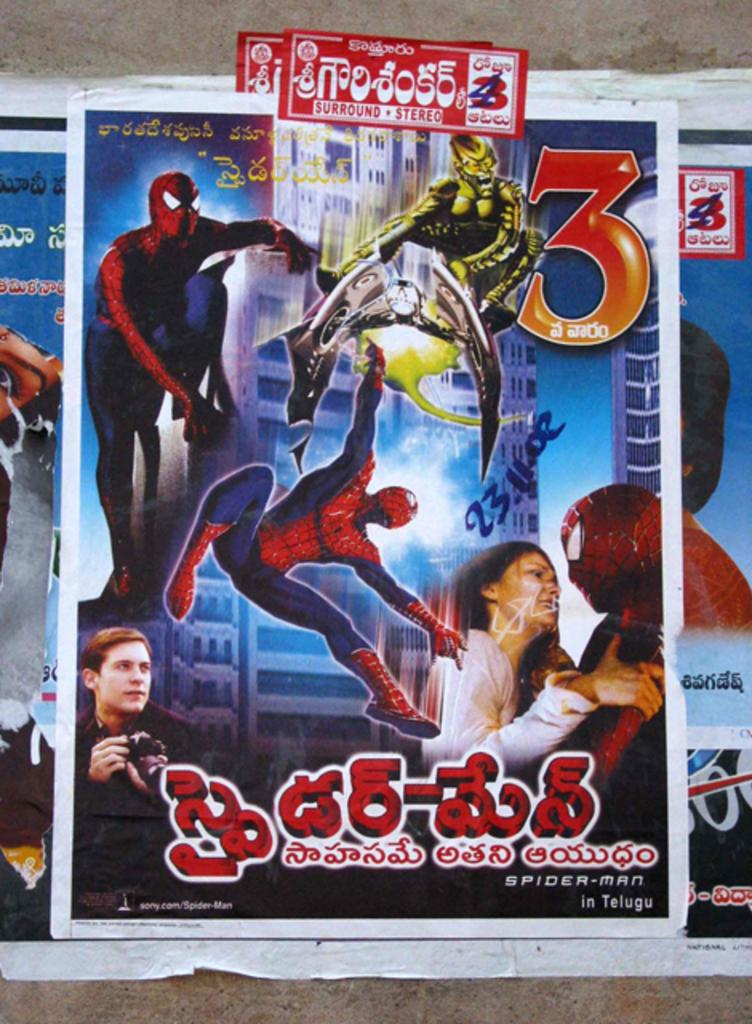What type of movie-related items are on the wall in the image? There are posts related to a Spider-Man movie on the wall. What type of paste is being used to hold the yam on the wall in the image? There is no yam or paste present in the image; it only features posts related to a Spider-Man movie on the wall. 